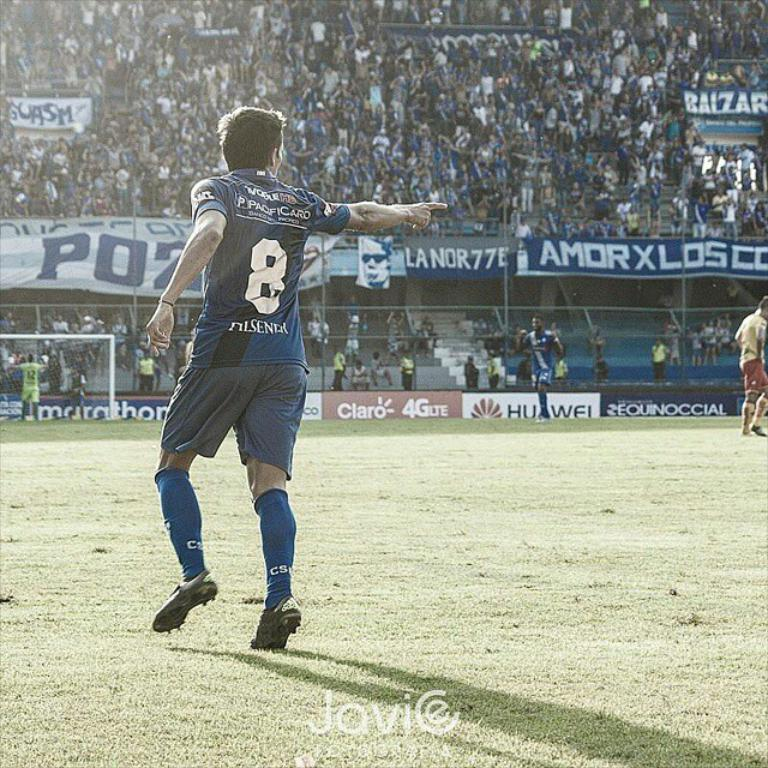<image>
Offer a succinct explanation of the picture presented. A soccer player wearing number 8 on a grassy soccer field. 